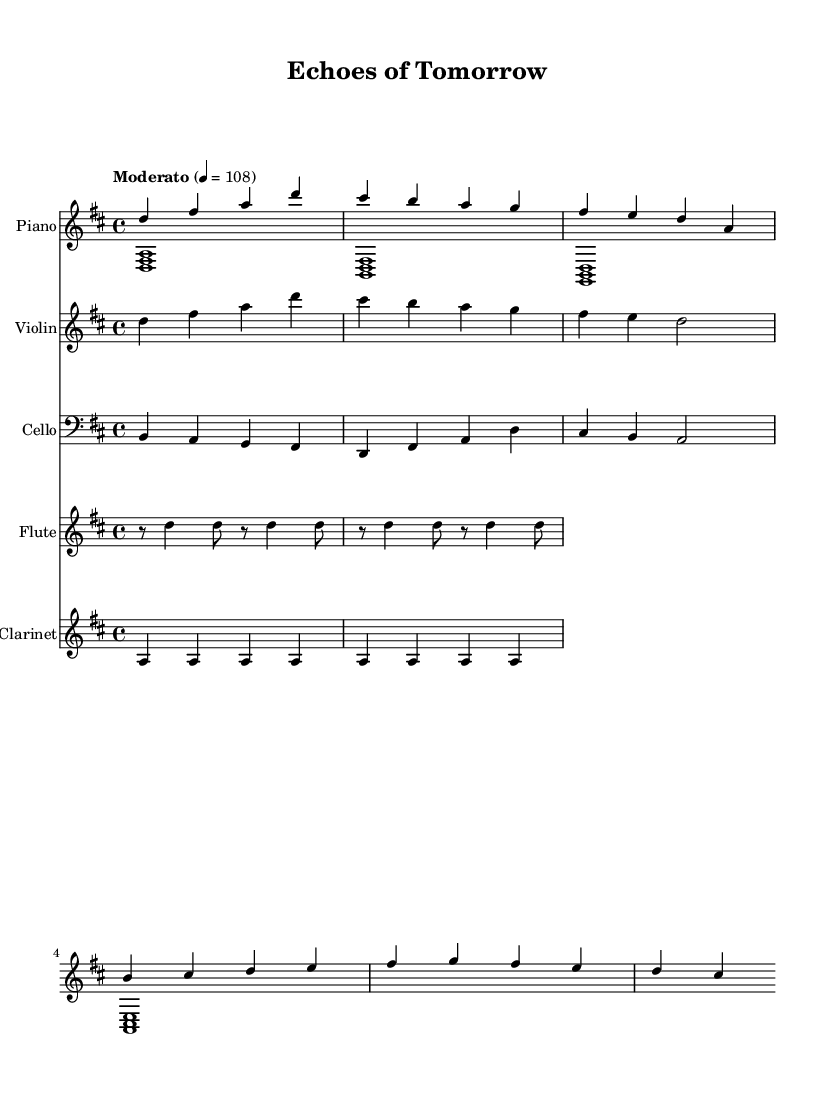What is the key signature of this music? The key signature displayed at the beginning of the score indicates D major, which has two sharps (F# and C#). This is determined by looking at the key signature symbol next to the clef.
Answer: D major What is the time signature of this music? The time signature shown in the score indicates 4/4, which means there are four beats in each measure and the quarter note gets the beat. This can be confirmed by checking the time signature notation next to the key signature.
Answer: 4/4 What is the tempo marking for this music? The tempo marking indicates "Moderato" with a metronome marking of 108. This implies a moderate speed where the quarter note is played at 108 beats per minute. This is observed in the tempo indication in the score.
Answer: Moderato, 108 Which instrument plays the main theme? The main theme is introduced by the piano right hand, as it is the first part to present the primary melodic material of the composition. This can be identified by looking at the initial notes played by the piano RH staff.
Answer: Piano What are the names of the leitmotifs in this composition? The two leitmotifs identified in this score are the "Hope" leitmotif played by the violin and the "Struggle" leitmotif played by the cello. This is based on the specific passages labeled as such in the music.
Answer: Hope and Struggle How many instruments are included in this score? The score includes five different instruments: Piano, Violin, Cello, Flute, and Clarinet. This can be determined by counting the individual staves labeled with each instrument's name.
Answer: Five instruments What is the role of counterpoint in this music? The counterpoint is provided by the interaction between the piano left hand and the cello, creating a rich texture. This is discerned from observing the independent melodic lines that move against each other while harmonically supporting the main theme.
Answer: Create richness 